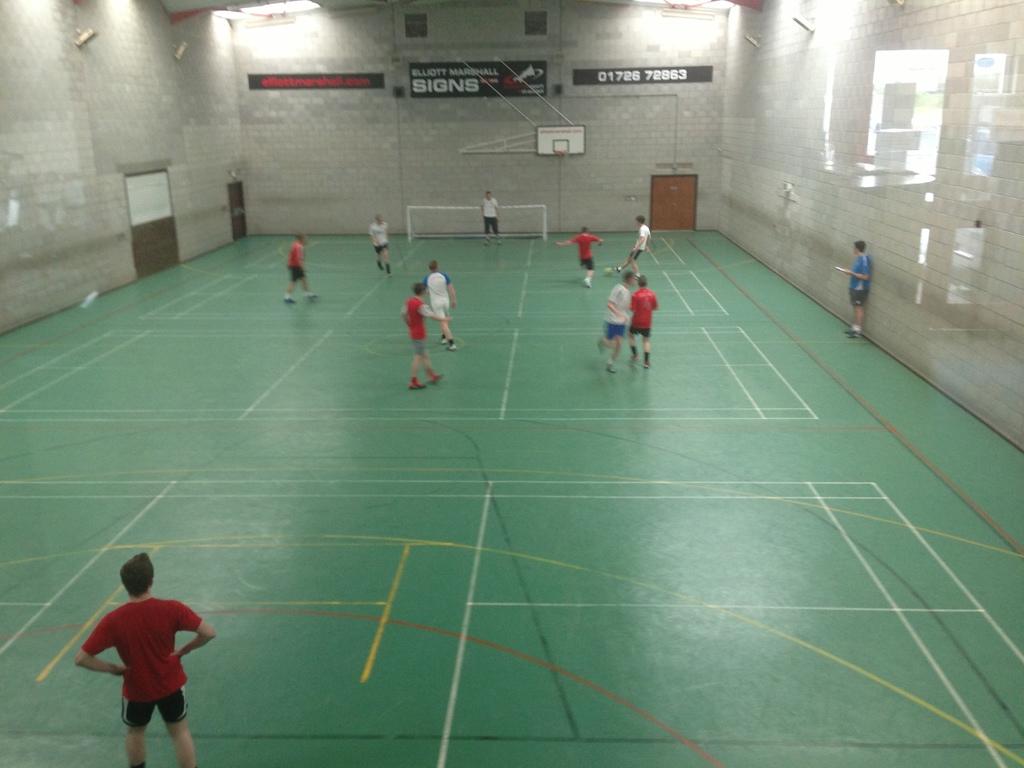What are the numbers on the right?
Ensure brevity in your answer.  01726 72863. 